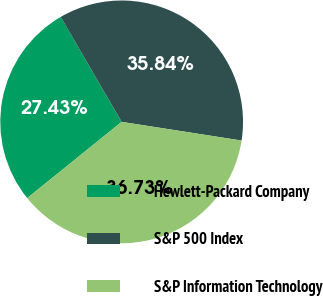<chart> <loc_0><loc_0><loc_500><loc_500><pie_chart><fcel>Hewlett-Packard Company<fcel>S&P 500 Index<fcel>S&P Information Technology<nl><fcel>27.43%<fcel>35.84%<fcel>36.73%<nl></chart> 